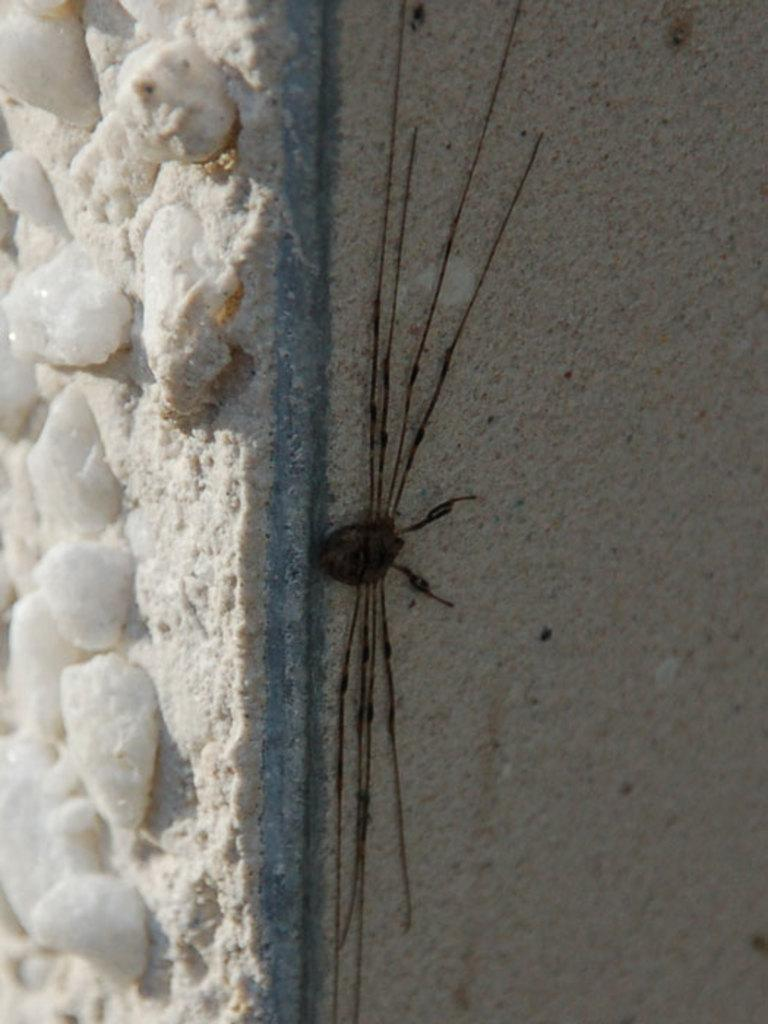What type of creature can be seen in the image? There is an insect in the image. Where is the insect located? The insect is on the sand in the image. What is the primary element in the foreground of the image? The sand is in the foreground of the image. What type of weather condition is depicted in the image? There is snow in the image. What type of acoustics can be heard from the insect in the image? There is no sound or acoustics associated with the insect in the image, as it is a still photograph. 